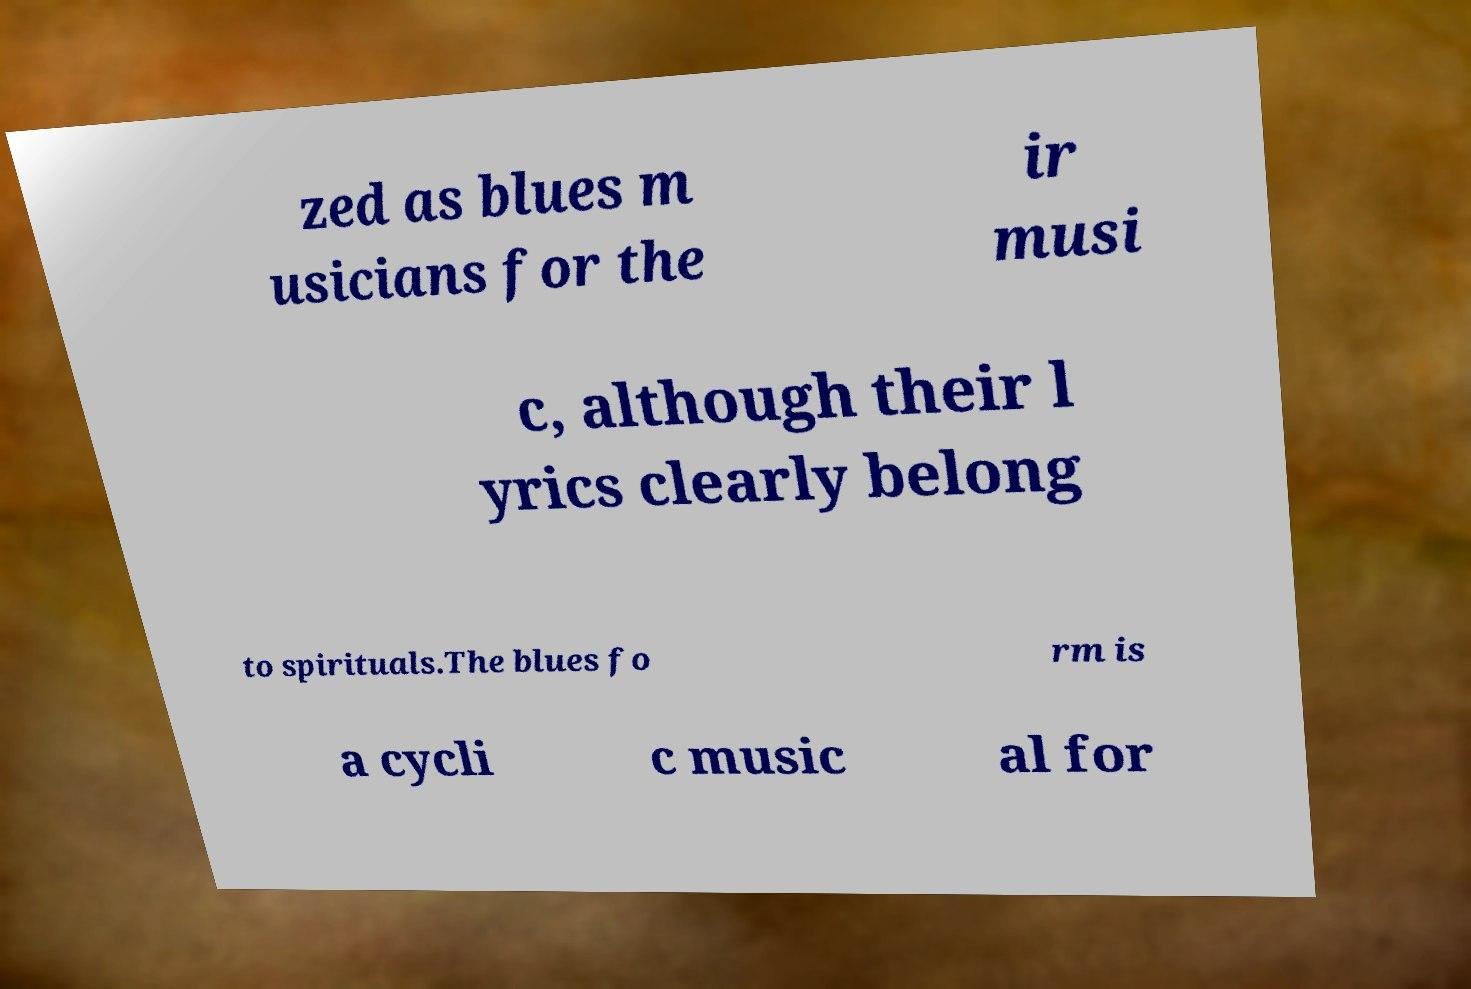Can you read and provide the text displayed in the image?This photo seems to have some interesting text. Can you extract and type it out for me? zed as blues m usicians for the ir musi c, although their l yrics clearly belong to spirituals.The blues fo rm is a cycli c music al for 